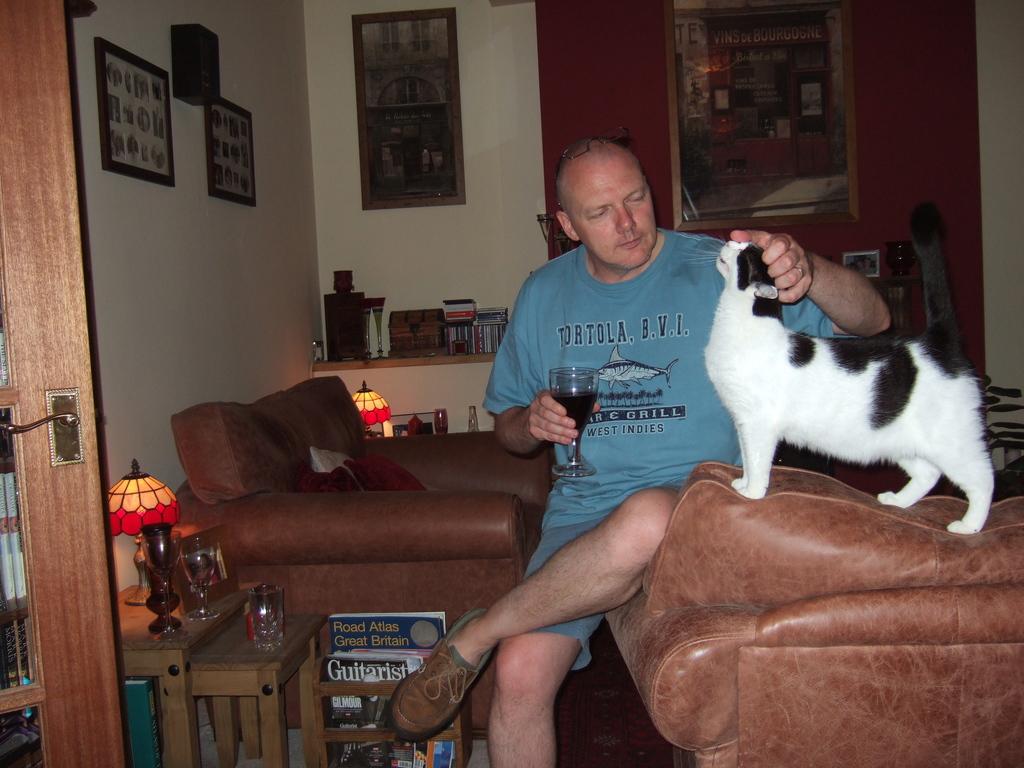Where is the location on the man's shirt?
Ensure brevity in your answer.  West indies. What kind of magazine is that at the bottom?
Provide a short and direct response. Guitarist. 